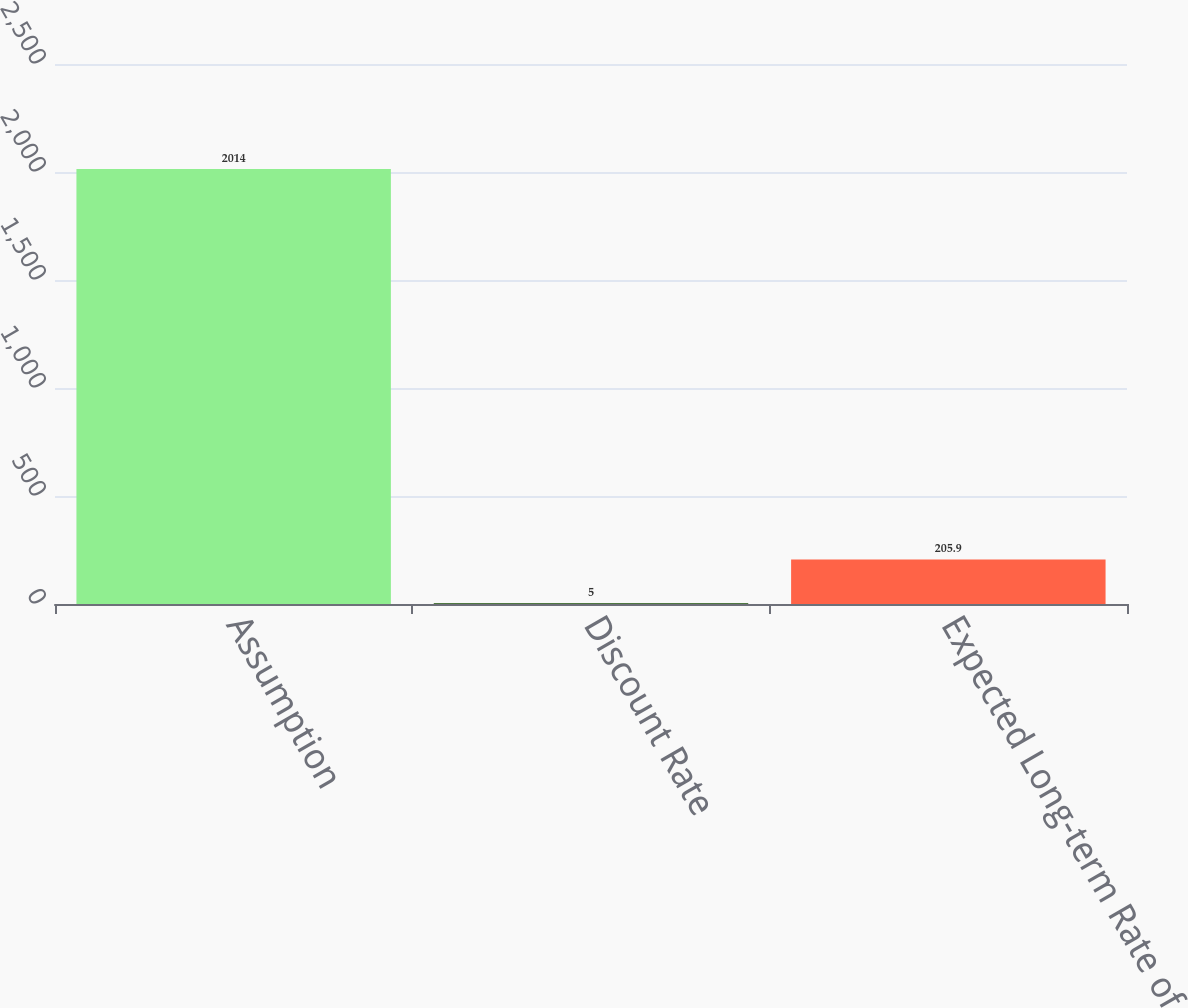<chart> <loc_0><loc_0><loc_500><loc_500><bar_chart><fcel>Assumption<fcel>Discount Rate<fcel>Expected Long-term Rate of<nl><fcel>2014<fcel>5<fcel>205.9<nl></chart> 